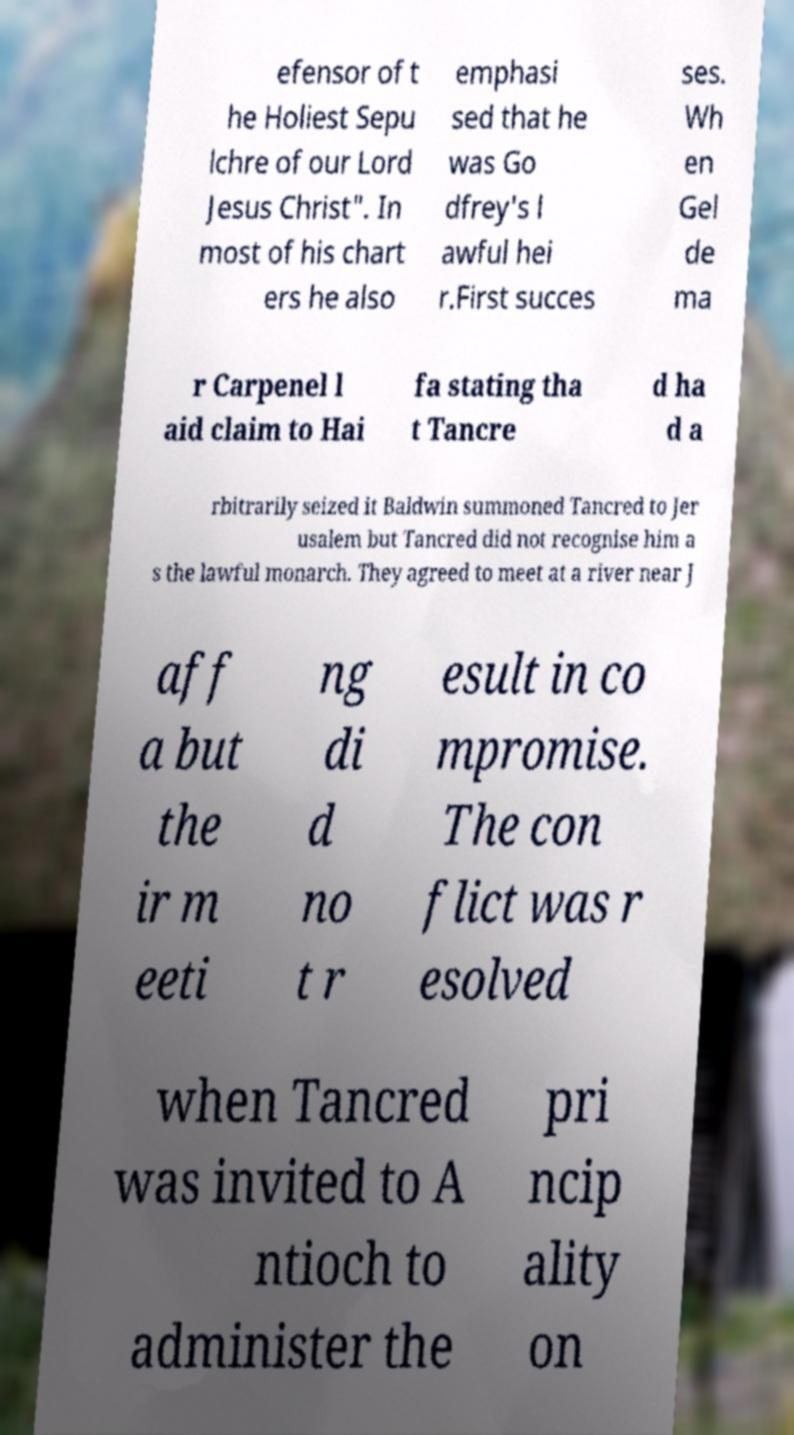Could you extract and type out the text from this image? efensor of t he Holiest Sepu lchre of our Lord Jesus Christ". In most of his chart ers he also emphasi sed that he was Go dfrey's l awful hei r.First succes ses. Wh en Gel de ma r Carpenel l aid claim to Hai fa stating tha t Tancre d ha d a rbitrarily seized it Baldwin summoned Tancred to Jer usalem but Tancred did not recognise him a s the lawful monarch. They agreed to meet at a river near J aff a but the ir m eeti ng di d no t r esult in co mpromise. The con flict was r esolved when Tancred was invited to A ntioch to administer the pri ncip ality on 